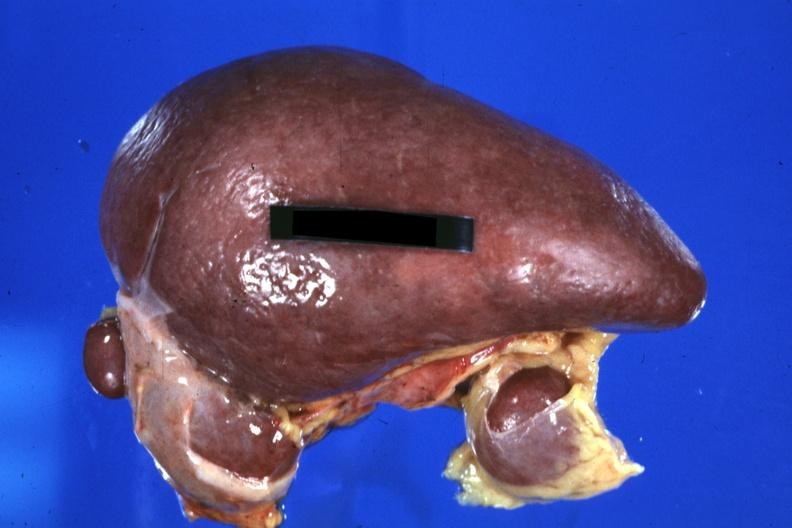s polysplenia present?
Answer the question using a single word or phrase. Yes 